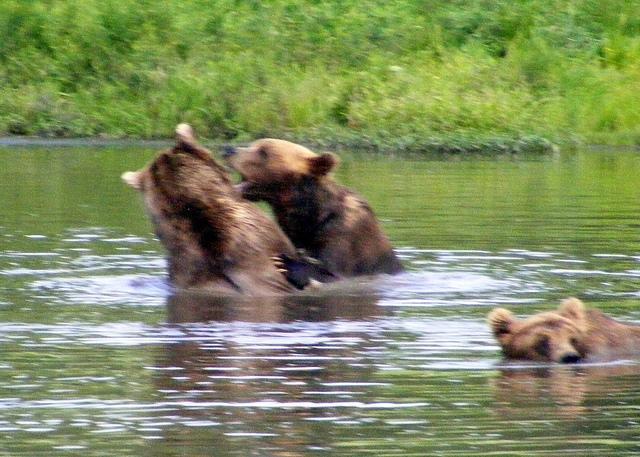How many bears are shown?
Give a very brief answer. 3. How many bears are visible?
Give a very brief answer. 3. 